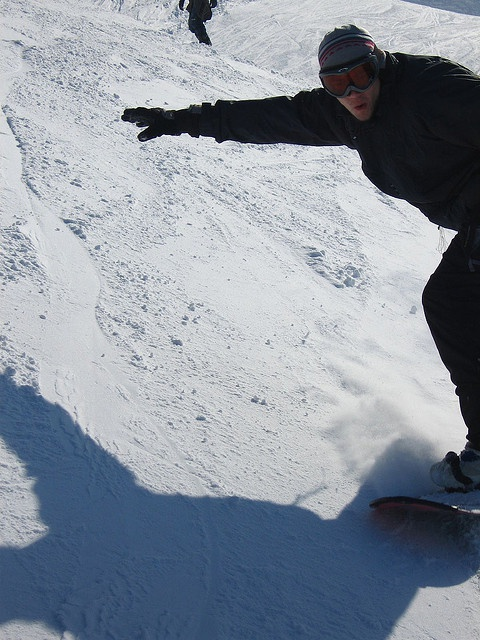Describe the objects in this image and their specific colors. I can see people in darkgray, black, lightgray, and gray tones, snowboard in darkgray, black, navy, darkblue, and gray tones, and people in darkgray, black, and gray tones in this image. 